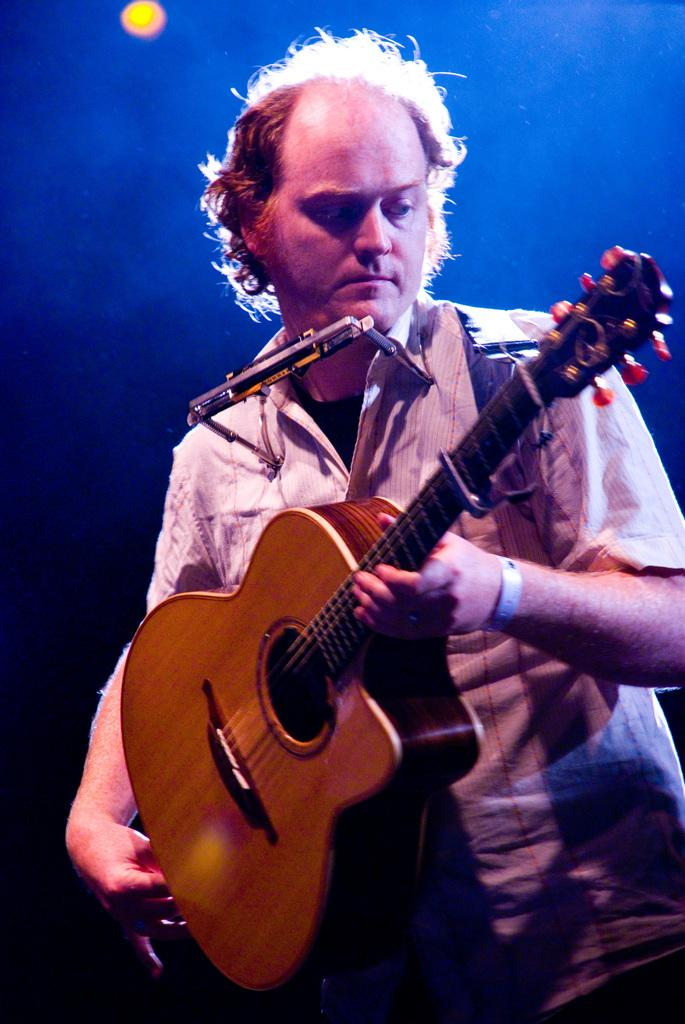What is the man in the image doing? The man is playing a guitar in the image. Can you describe the activity the man is engaged in? The man is playing a musical instrument, specifically a guitar. What can be seen in the image that provides illumination? There is a light source in the image. How many pigs are visible in the image? There are no pigs present in the image. What type of lead is being used by the man in the image? The man is playing a guitar, not using any type of lead. 